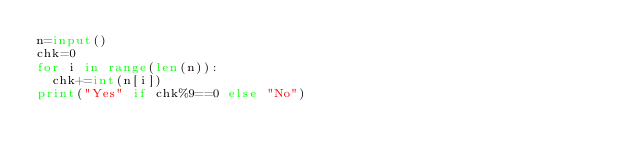<code> <loc_0><loc_0><loc_500><loc_500><_Python_>n=input()
chk=0
for i in range(len(n)):
  chk+=int(n[i])
print("Yes" if chk%9==0 else "No")
</code> 